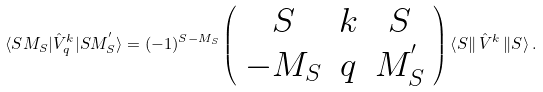Convert formula to latex. <formula><loc_0><loc_0><loc_500><loc_500>\langle S M _ { S } | { \hat { V } } ^ { k } _ { q } | S M _ { S } ^ { ^ { \prime } } \rangle = ( - 1 ) ^ { S - M _ { S } } \left ( \begin{array} { c c c } S & k & S \\ - M _ { S } & q & M _ { S } ^ { ^ { \prime } } \end{array} \right ) \left \langle S \right \| { \hat { V } } ^ { k } \left \| S \right \rangle .</formula> 